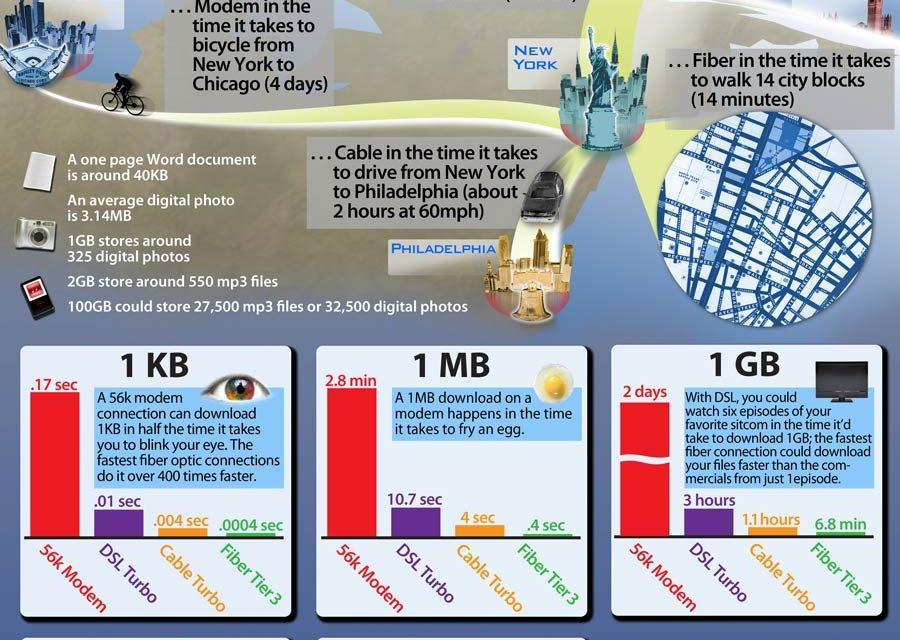Point out several critical features in this image. DSL Turbo allows for the rapid download of up to 1 kilobyte of data in just 0.01 seconds. The 56k modem takes the longest time to download the user's favorite sitcom. There are three methods of transmitting data: modem, cable, and fiber. The amount of data that can be downloaded with Cable Turbo in 1.1 hours is 1 GB. The Fiber Tier 3 can download a significant amount of data in just 0.4 seconds, approximately equal to 1 MB of data. 